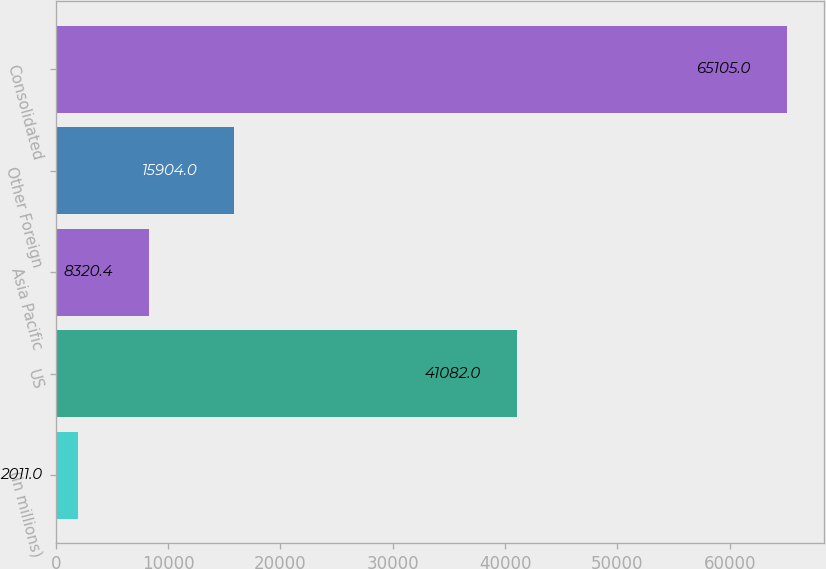Convert chart. <chart><loc_0><loc_0><loc_500><loc_500><bar_chart><fcel>(in millions)<fcel>US<fcel>Asia Pacific<fcel>Other Foreign<fcel>Consolidated<nl><fcel>2011<fcel>41082<fcel>8320.4<fcel>15904<fcel>65105<nl></chart> 